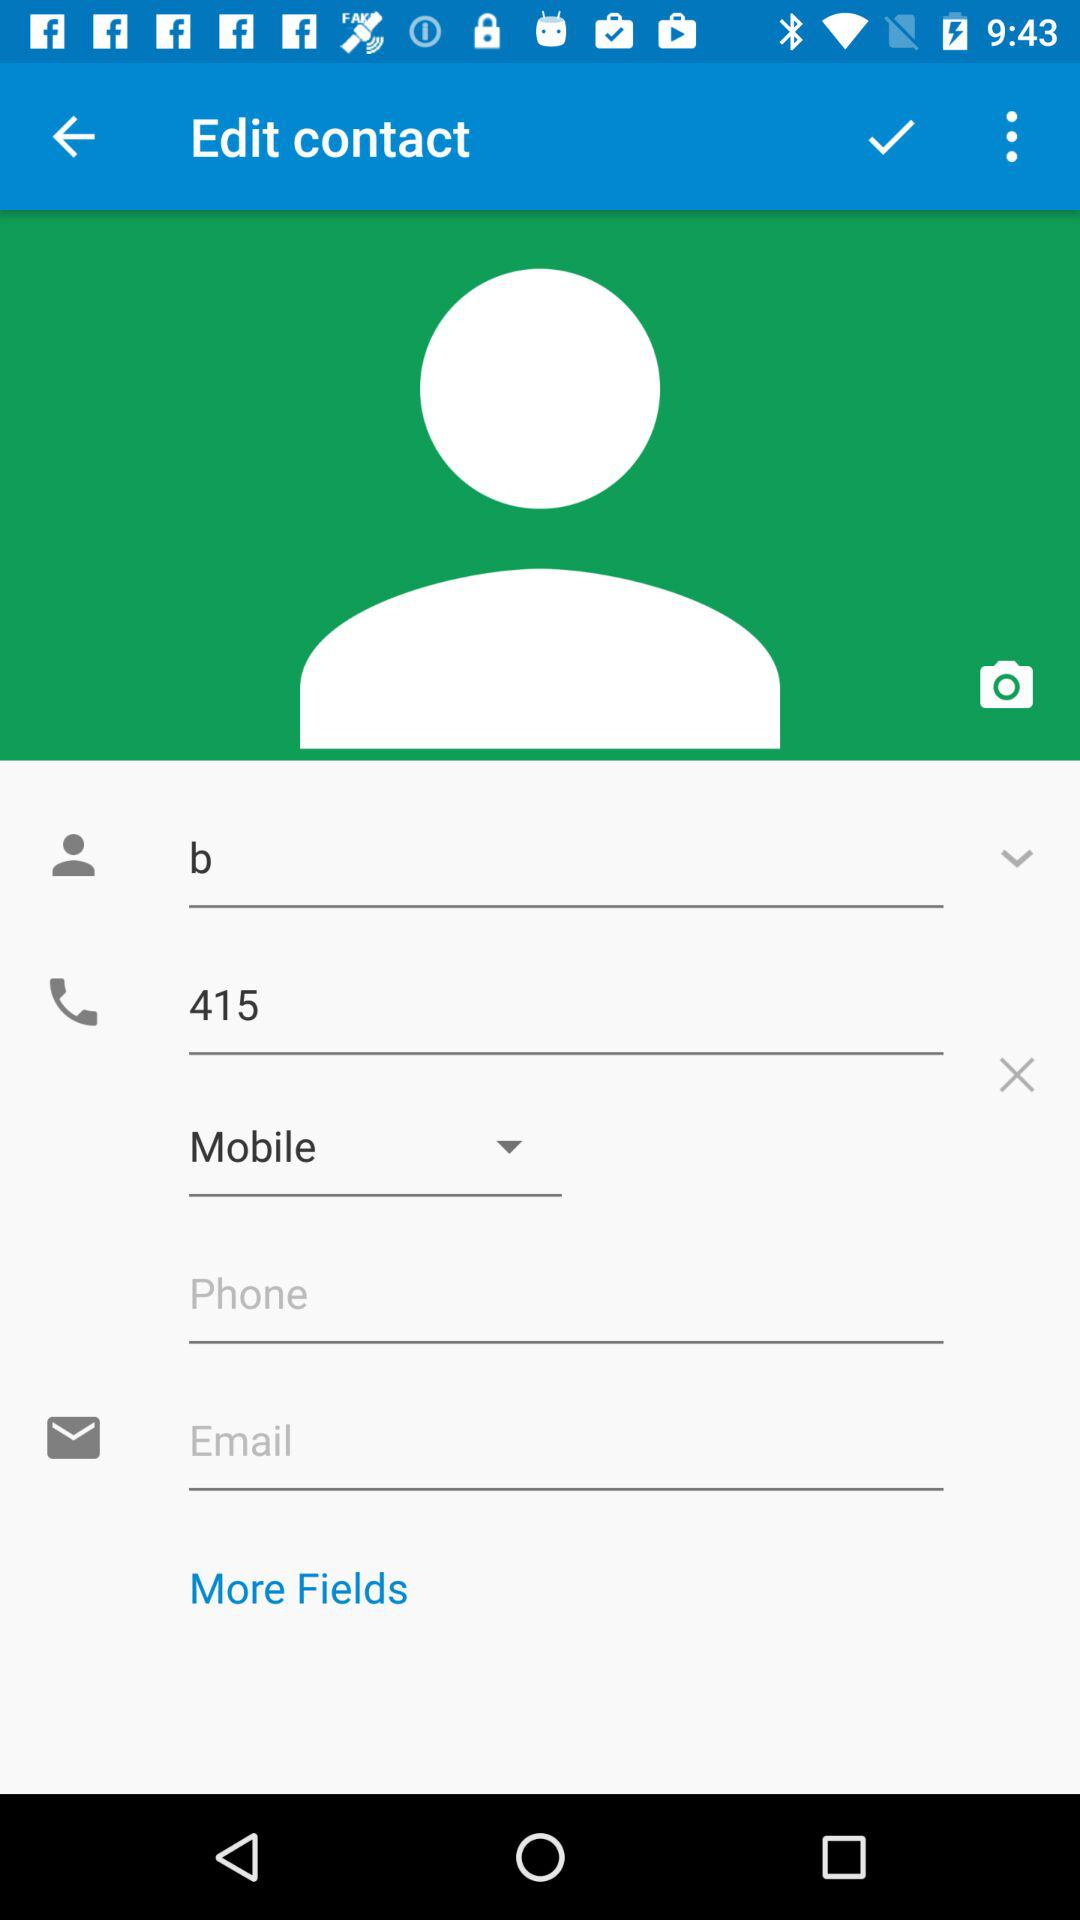How many fields are there that allow the user to enter a phone number?
Answer the question using a single word or phrase. 2 